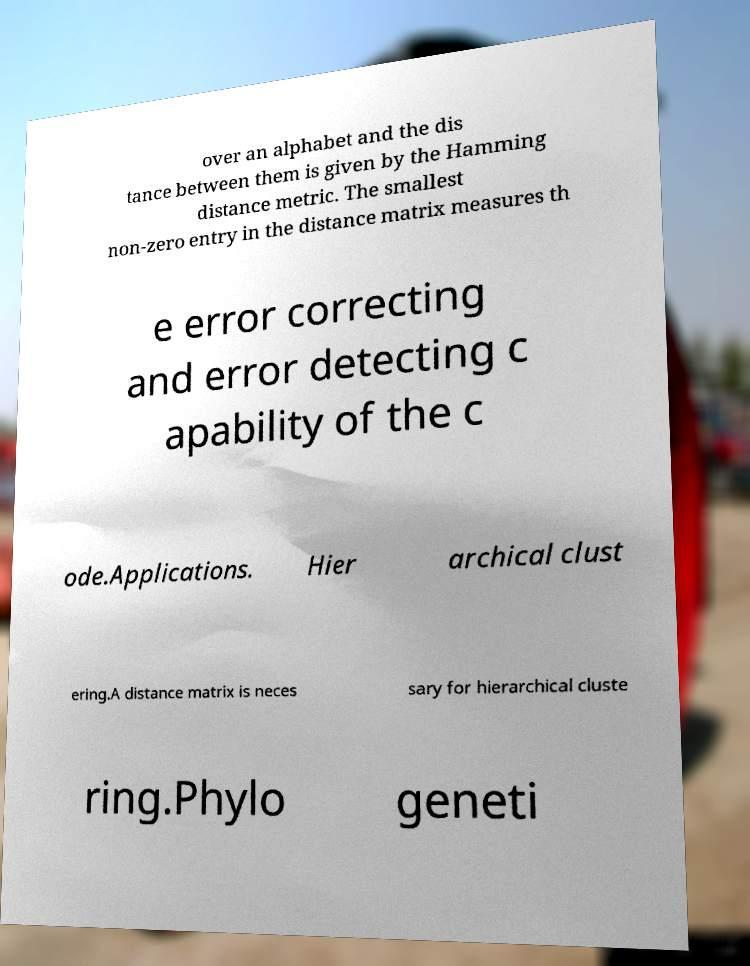Could you extract and type out the text from this image? over an alphabet and the dis tance between them is given by the Hamming distance metric. The smallest non-zero entry in the distance matrix measures th e error correcting and error detecting c apability of the c ode.Applications. Hier archical clust ering.A distance matrix is neces sary for hierarchical cluste ring.Phylo geneti 